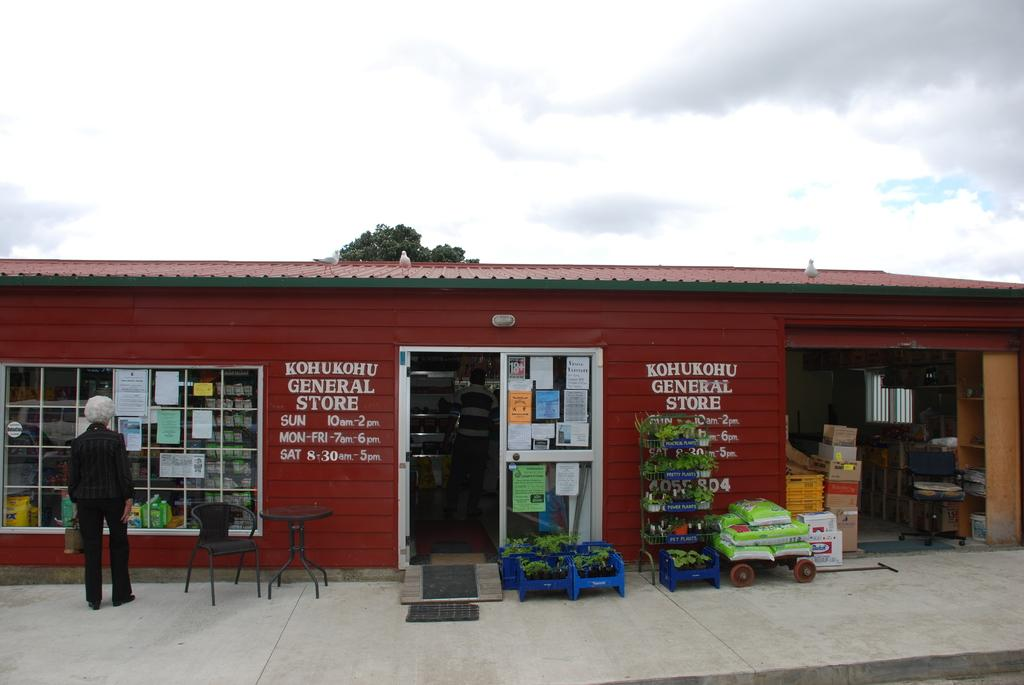<image>
Provide a brief description of the given image. Kohukohu general store with a red roof and walls 